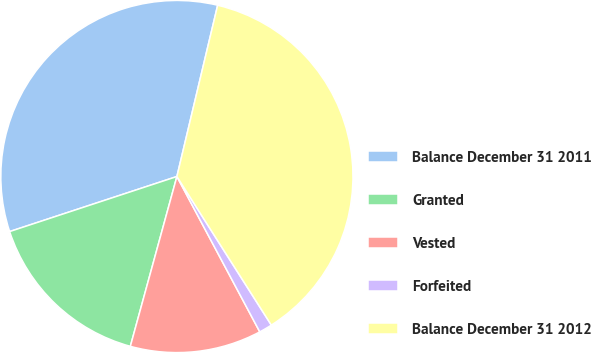<chart> <loc_0><loc_0><loc_500><loc_500><pie_chart><fcel>Balance December 31 2011<fcel>Granted<fcel>Vested<fcel>Forfeited<fcel>Balance December 31 2012<nl><fcel>33.78%<fcel>15.68%<fcel>12.06%<fcel>1.21%<fcel>37.27%<nl></chart> 